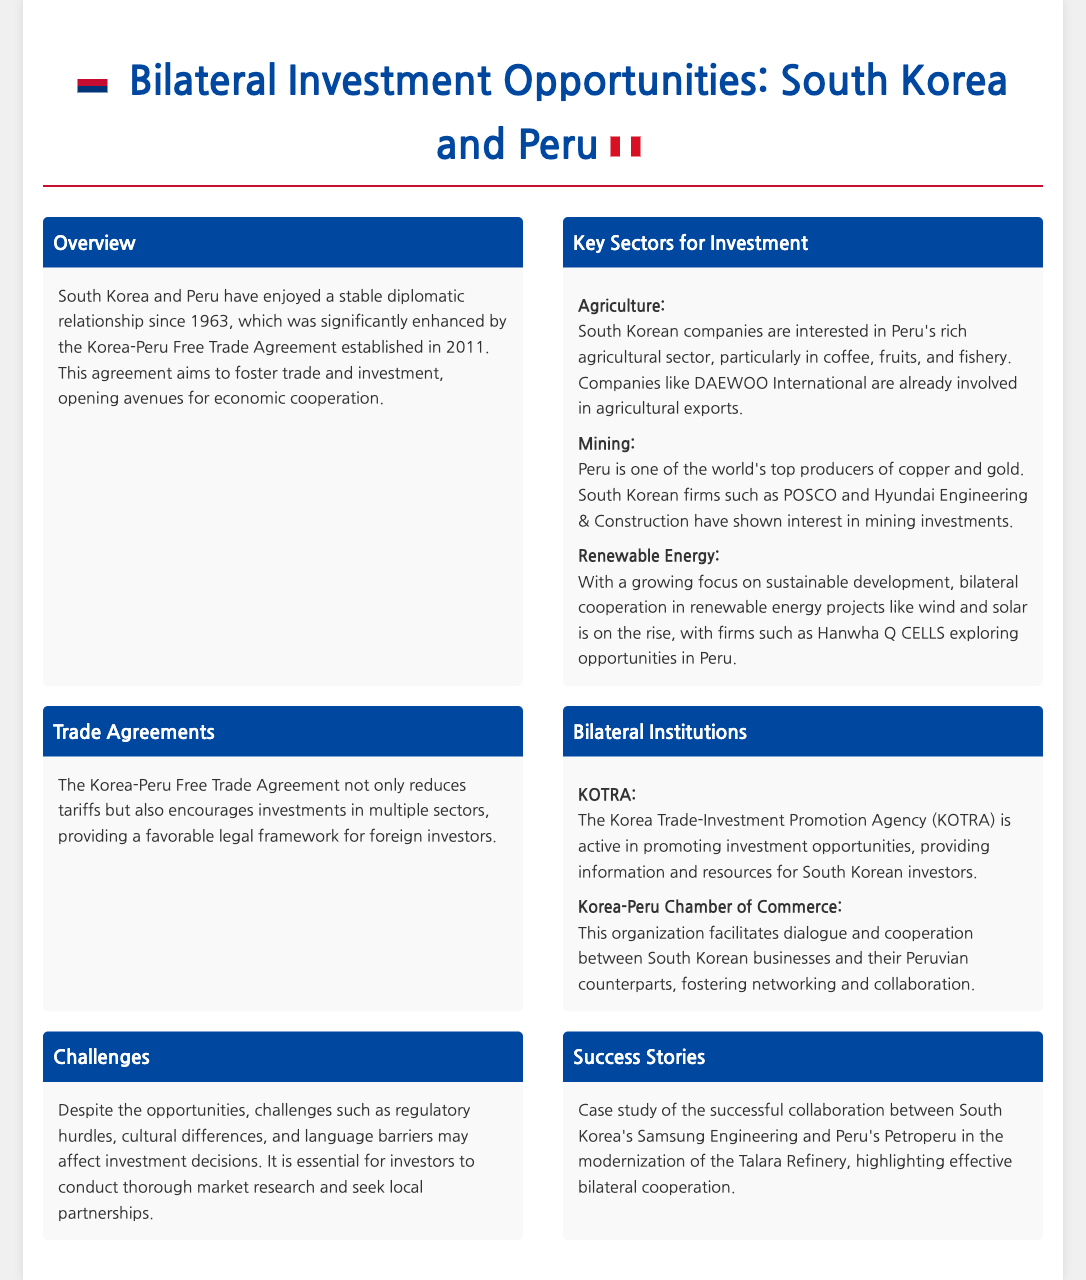What year was the Korea-Peru Free Trade Agreement established? The document states that the Korea-Peru Free Trade Agreement was established in 2011.
Answer: 2011 Which sector has South Korean companies shown interest in for agricultural investments? The document mentions that South Korean companies are particularly interested in coffee, fruits, and fishery in Peru's agricultural sector.
Answer: Coffee, fruits, and fishery What is the primary focus of the investment opportunities outlined in the document? The main focus of the investment opportunities discussed is the bilateral relations and cooperation between South Korea and Peru.
Answer: Bilateral relations and cooperation Name one South Korean firm interested in mining investments in Peru. The document lists POSCO and Hyundai Engineering & Construction as South Korean firms interested in mining investments in Peru.
Answer: POSCO What challenges are mentioned that may affect investment decisions? The document highlights regulatory hurdles, cultural differences, and language barriers as challenges affecting investment decisions.
Answer: Regulatory hurdles, cultural differences, language barriers Which institution is active in promoting investment opportunities for South Korean investors? The document states that the Korea Trade-Investment Promotion Agency (KOTRA) is active in promoting investment opportunities.
Answer: KOTRA What successful collaboration is highlighted in the success stories? The case study highlighted is the collaboration between South Korea's Samsung Engineering and Peru's Petroperu in the modernization of the Talara Refinery.
Answer: Samsung Engineering and Petroperu What does the Korea-Peru Free Trade Agreement reduce? The document specifies that the Korea-Peru Free Trade Agreement reduces tariffs.
Answer: Tariffs 